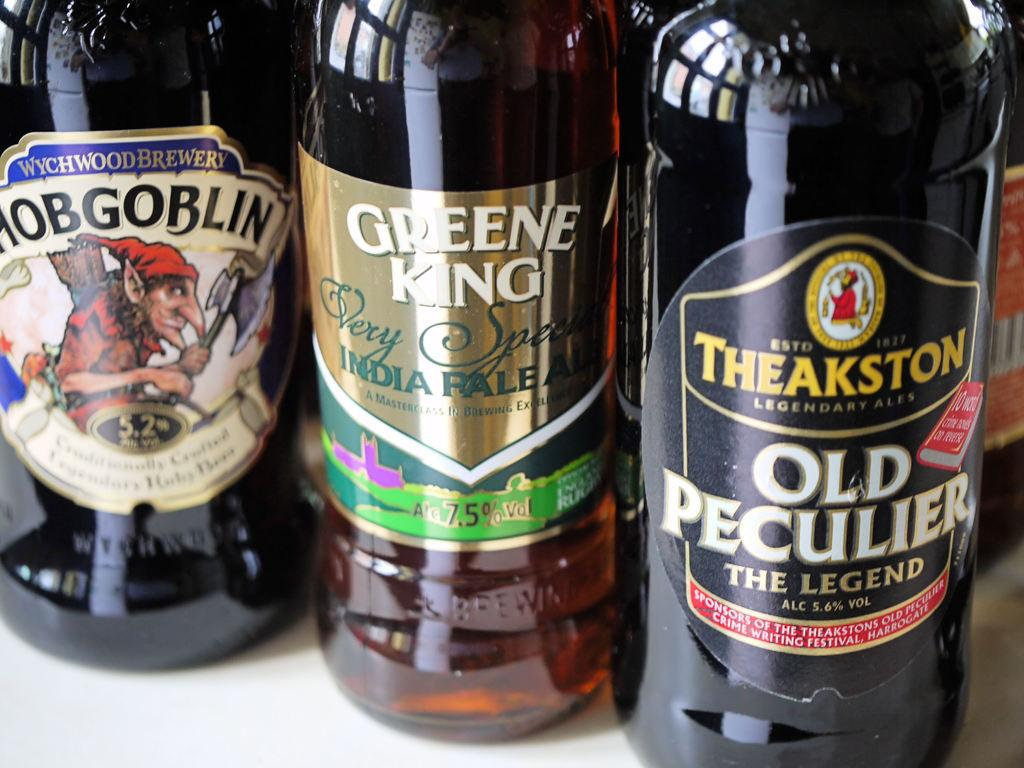<image>
Render a clear and concise summary of the photo. A bottle of Old Peculiar beer is on a table next to other types of beer. 